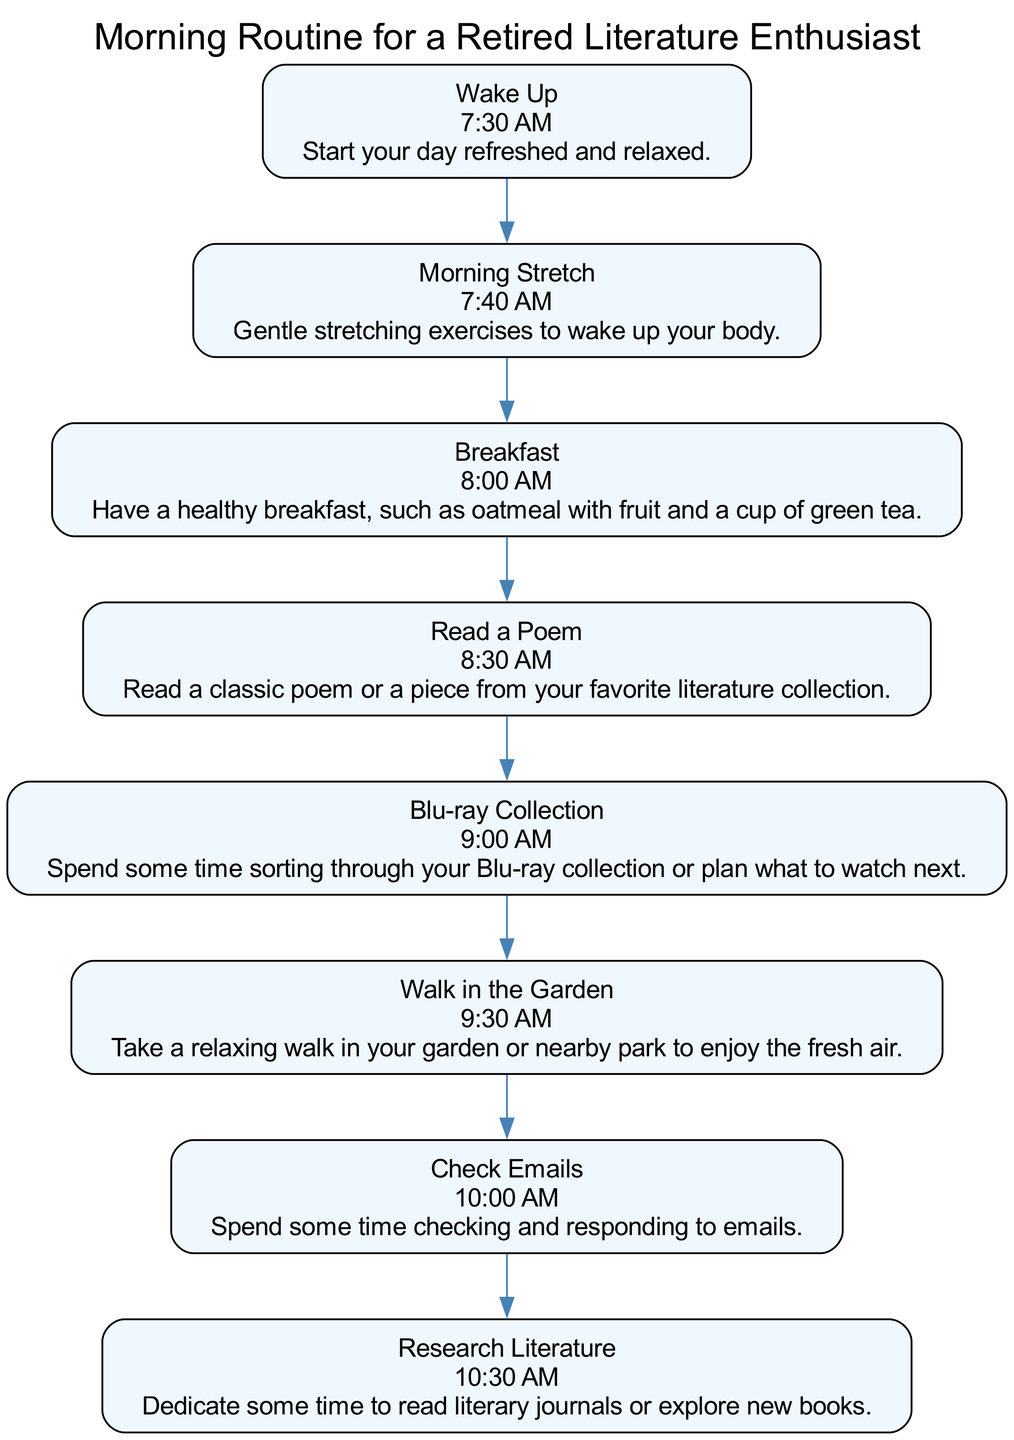What is the first activity in the morning routine? The first activity indicated in the diagram is "Wake Up", labeled with the time "7:30 AM". This activity starts the entire routine.
Answer: Wake Up What time is breakfast scheduled? The diagram specifies that breakfast occurs at "8:00 AM". By locating the "Breakfast" node, we can find the corresponding time directly associated with it.
Answer: 8:00 AM How many total activities are listed in the morning routine? The diagram contains a total of 8 distinct activities, which can be counted by the number of nodes present starting from "Wake Up" to "Research Literature".
Answer: 8 What is the last activity before checking emails? The last activity before "Check Emails" is "Walk in the Garden". This can be discerned by following the directional flow from "Walk in the Garden" to "Check Emails".
Answer: Walk in the Garden At what time does the "Research Literature" activity take place? The activity "Research Literature" is scheduled for "10:30 AM", as indicated directly in its node within the diagram.
Answer: 10:30 AM What common element do "Morning Stretch" and "Breakfast" share? Both activities are consecutive in the diagram, with "Morning Stretch" leading directly to "Breakfast". They share a placement in the overall morning routine, emphasizing physical and nourishment aspects.
Answer: Consecutive activities Which activity occurs immediately after reading a poem? Following "Read a Poem", the next activity is "Blu-ray Collection", which can be identified by tracing the flow from the "Read a Poem" node to the one that follows it.
Answer: Blu-ray Collection What is the purpose of the "Walk in the Garden" activity? The purpose of "Walk in the Garden," as described in its details, is to take a relaxing stroll to enjoy fresh air. This reflects a focus on leisure and well-being.
Answer: Enjoy fresh air What is the earliest scheduled activity? The earliest activity on the diagram is "Wake Up", which commences at "7:30 AM", as noted in the sequence of the morning routine.
Answer: 7:30 AM 